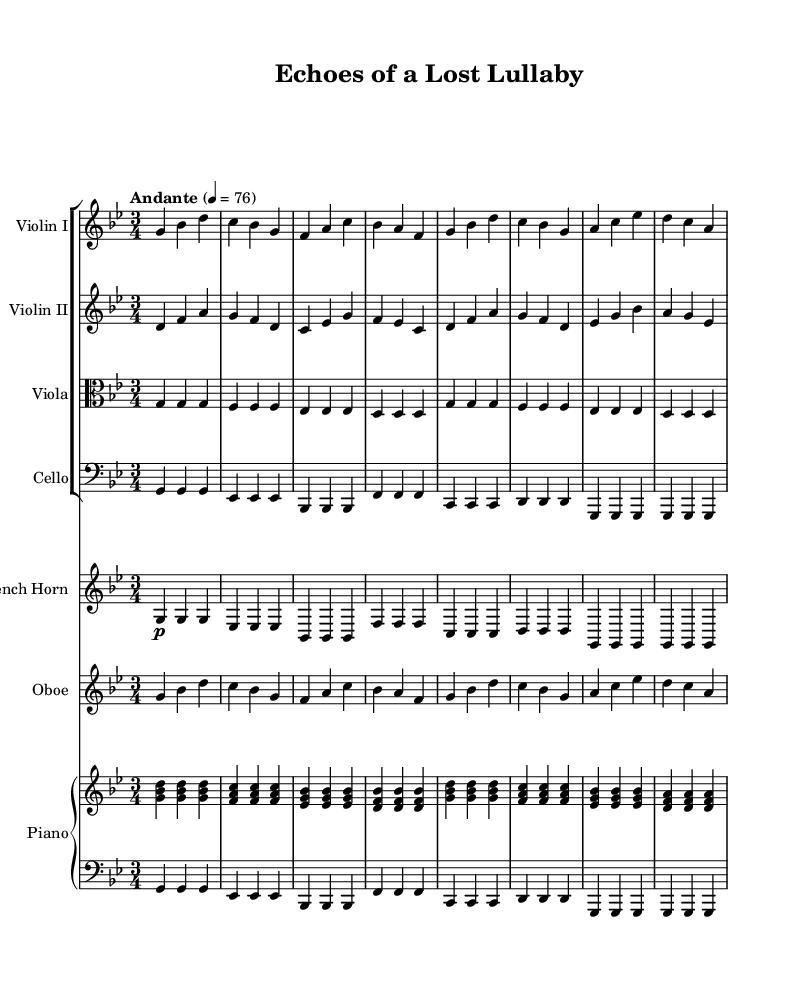what is the key signature of this music? The key signature is indicated at the beginning of the partiture. The presence of flats indicates that it is in a minor key. Counting the flats, we find six, which corresponds to G minor.
Answer: G minor what is the time signature of this music? The time signature is located right after the key signature and shows how the beats are organized in each measure. Here, it is three beats per measure, indicated as 3/4.
Answer: 3/4 what is the tempo marking for this piece? The tempo marking appears above the staff and indicates the speed of the music. It is marked as "Andante," which refers to a moderate walking pace, and there is a metronome mark of 76 beats per minute.
Answer: Andante which instruments are featured in the symphony? The instruments can be identified by their respective staves at the beginning of each section. The score includes Violin I, Violin II, Viola, Cello, French Horn, Oboe, and Piano.
Answer: Violin I, Violin II, Viola, Cello, French Horn, Oboe, Piano how many measures are there in the violin I part? The total number of measures can be determined by counting the groups of notes separated by vertical bars in the violin I part. Upon inspection, there are eight measures written in that part.
Answer: 8 which instrument plays the melody most prominently? To determine the main melodic instrument, one must analyze which part has the most distinct and prominent melodic lines. In this case, the Violin I clearly has the leading melody throughout the piece.
Answer: Violin I what is the dynamic marking given for the French Horn? The dynamic marking is indicated on the staff and signifies how loud or soft the music should be played. The French Horn part starts with a piano marking, suggesting it should be played softly.
Answer: piano 